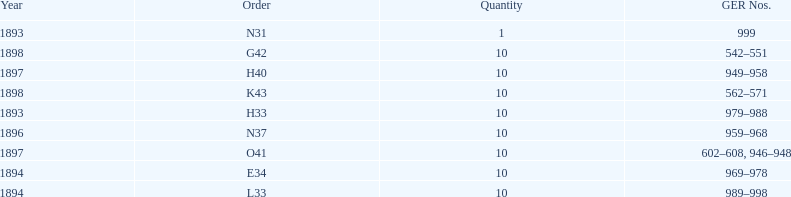What amount of time to the years span? 5 years. 